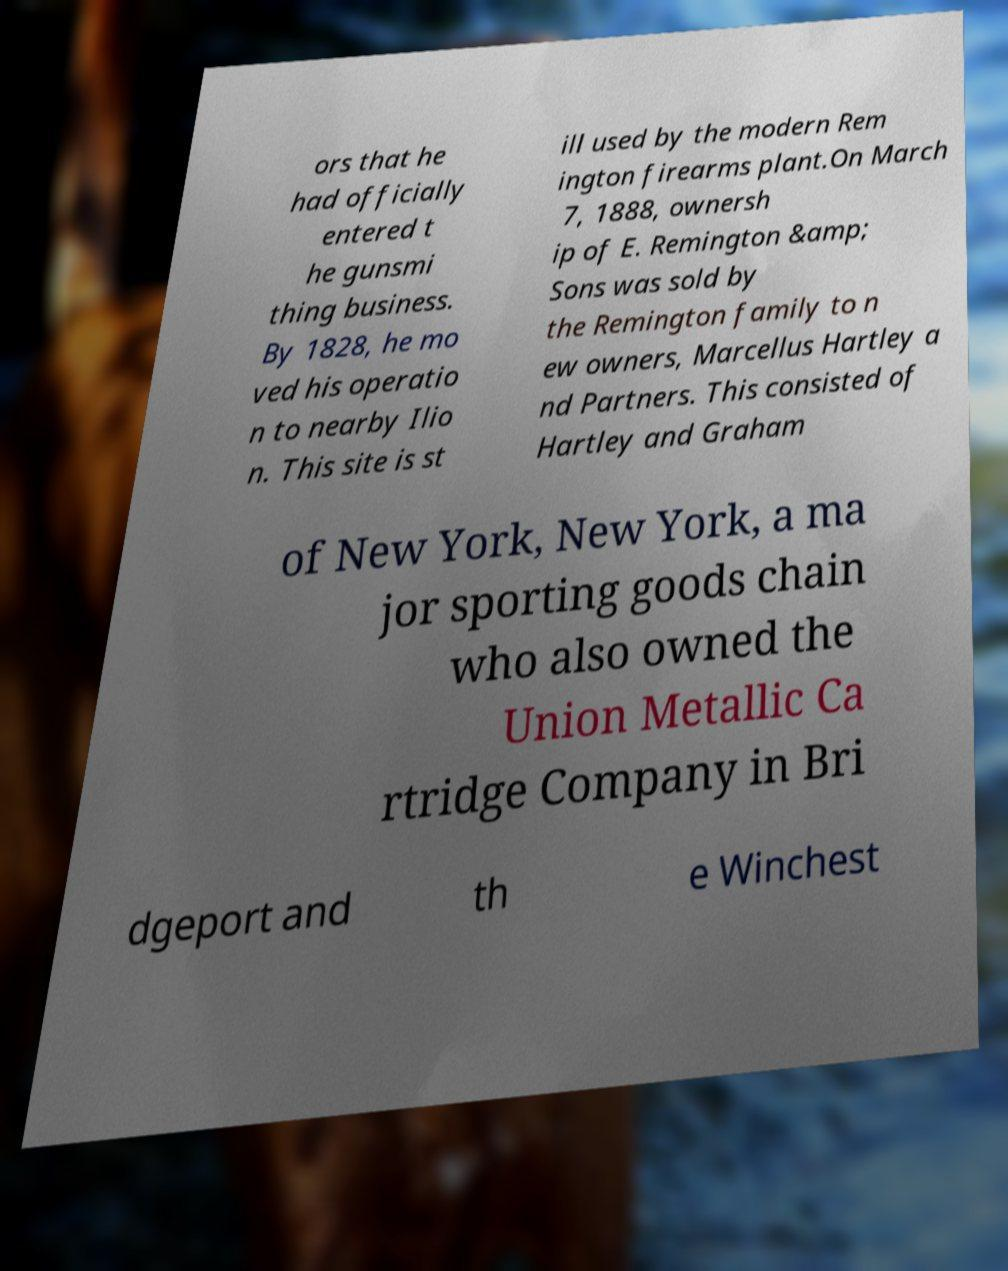Can you accurately transcribe the text from the provided image for me? ors that he had officially entered t he gunsmi thing business. By 1828, he mo ved his operatio n to nearby Ilio n. This site is st ill used by the modern Rem ington firearms plant.On March 7, 1888, ownersh ip of E. Remington &amp; Sons was sold by the Remington family to n ew owners, Marcellus Hartley a nd Partners. This consisted of Hartley and Graham of New York, New York, a ma jor sporting goods chain who also owned the Union Metallic Ca rtridge Company in Bri dgeport and th e Winchest 